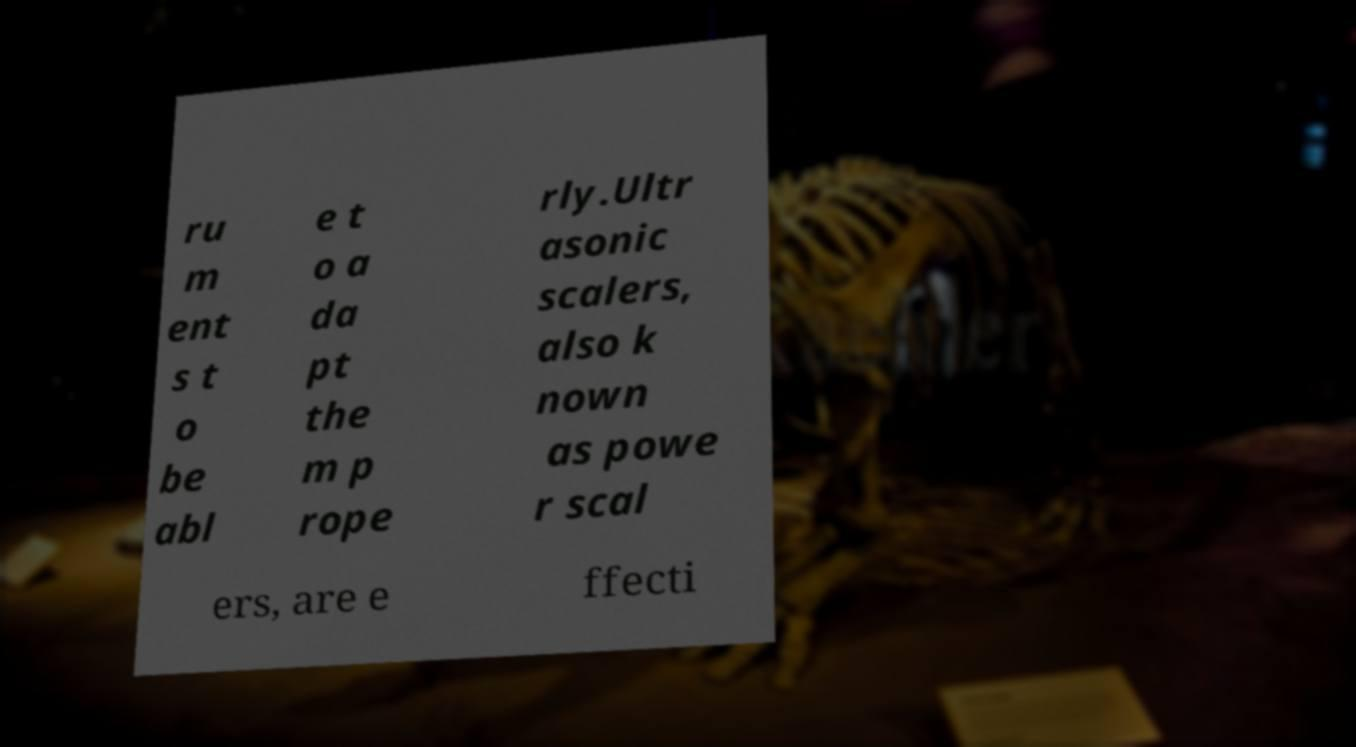I need the written content from this picture converted into text. Can you do that? ru m ent s t o be abl e t o a da pt the m p rope rly.Ultr asonic scalers, also k nown as powe r scal ers, are e ffecti 